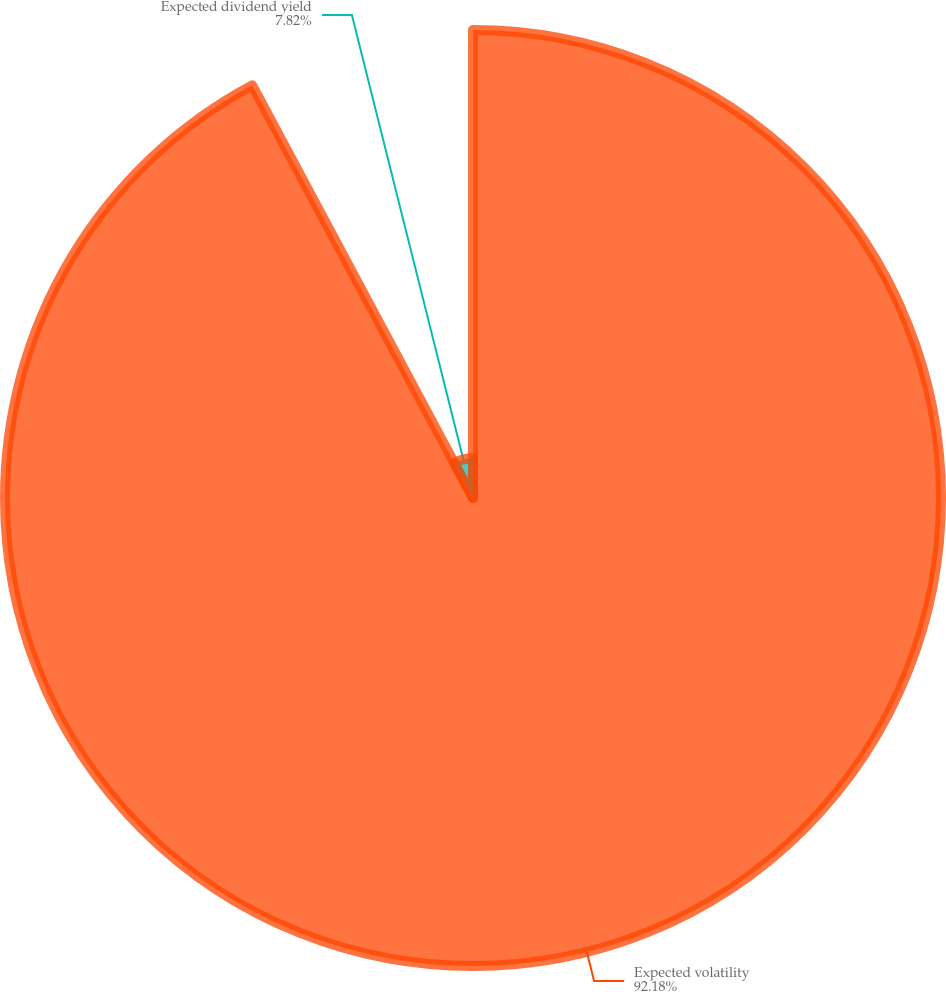<chart> <loc_0><loc_0><loc_500><loc_500><pie_chart><fcel>Expected volatility<fcel>Expected dividend yield<nl><fcel>92.18%<fcel>7.82%<nl></chart> 